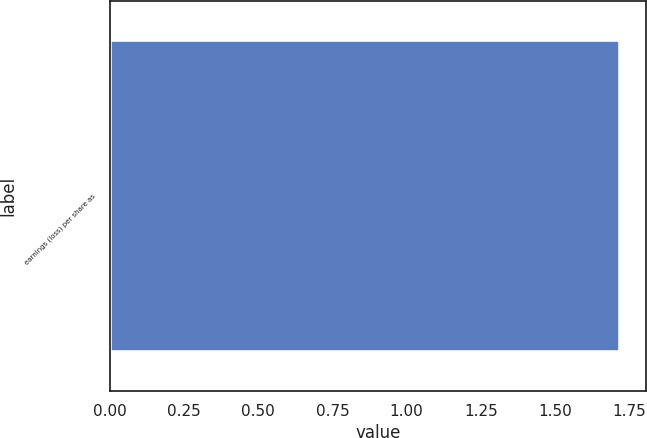Convert chart to OTSL. <chart><loc_0><loc_0><loc_500><loc_500><bar_chart><fcel>earnings (loss) per share as<nl><fcel>1.72<nl></chart> 